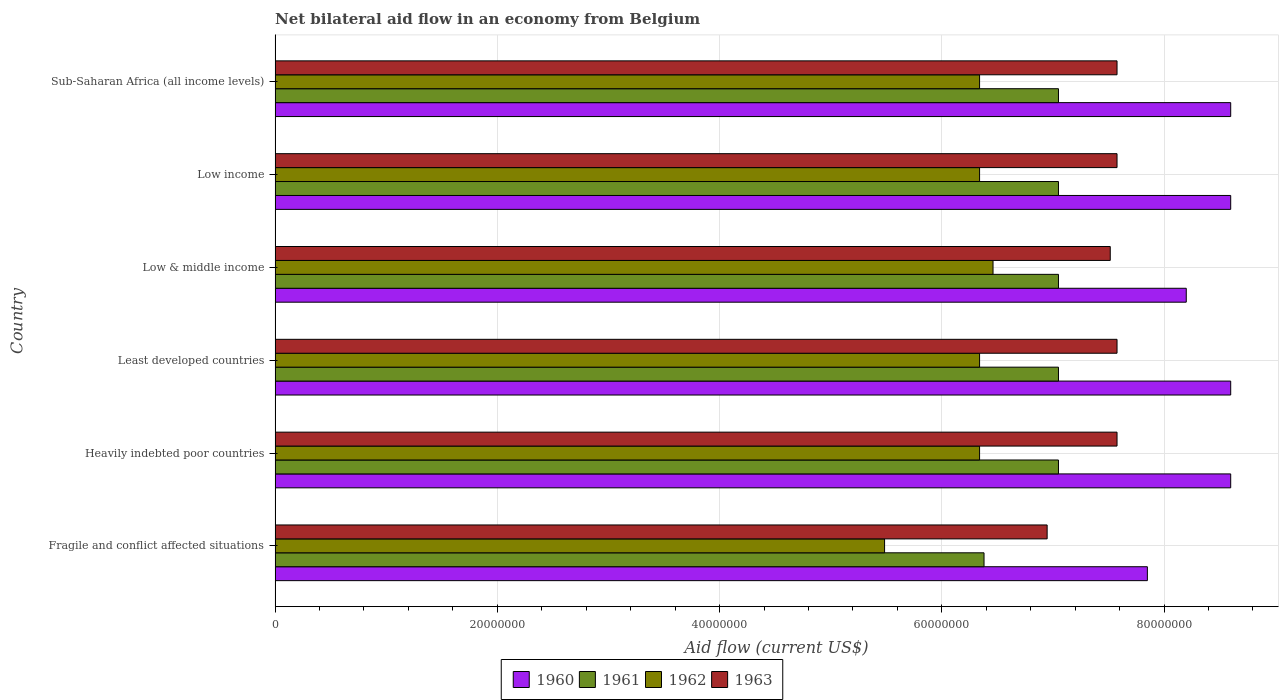Are the number of bars on each tick of the Y-axis equal?
Provide a succinct answer. Yes. How many bars are there on the 3rd tick from the top?
Offer a terse response. 4. How many bars are there on the 4th tick from the bottom?
Provide a succinct answer. 4. In how many cases, is the number of bars for a given country not equal to the number of legend labels?
Offer a very short reply. 0. What is the net bilateral aid flow in 1962 in Least developed countries?
Make the answer very short. 6.34e+07. Across all countries, what is the maximum net bilateral aid flow in 1961?
Your answer should be compact. 7.05e+07. Across all countries, what is the minimum net bilateral aid flow in 1963?
Make the answer very short. 6.95e+07. In which country was the net bilateral aid flow in 1960 maximum?
Your answer should be very brief. Heavily indebted poor countries. In which country was the net bilateral aid flow in 1960 minimum?
Offer a terse response. Fragile and conflict affected situations. What is the total net bilateral aid flow in 1961 in the graph?
Your answer should be compact. 4.16e+08. What is the difference between the net bilateral aid flow in 1963 in Fragile and conflict affected situations and that in Heavily indebted poor countries?
Offer a terse response. -6.29e+06. What is the difference between the net bilateral aid flow in 1961 in Fragile and conflict affected situations and the net bilateral aid flow in 1962 in Least developed countries?
Make the answer very short. 4.00e+05. What is the average net bilateral aid flow in 1960 per country?
Provide a succinct answer. 8.41e+07. What is the difference between the net bilateral aid flow in 1962 and net bilateral aid flow in 1961 in Sub-Saharan Africa (all income levels)?
Keep it short and to the point. -7.10e+06. In how many countries, is the net bilateral aid flow in 1963 greater than 64000000 US$?
Your answer should be very brief. 6. What is the ratio of the net bilateral aid flow in 1962 in Fragile and conflict affected situations to that in Sub-Saharan Africa (all income levels)?
Ensure brevity in your answer.  0.87. Is the net bilateral aid flow in 1961 in Heavily indebted poor countries less than that in Low income?
Your response must be concise. No. Is the difference between the net bilateral aid flow in 1962 in Low income and Sub-Saharan Africa (all income levels) greater than the difference between the net bilateral aid flow in 1961 in Low income and Sub-Saharan Africa (all income levels)?
Provide a succinct answer. No. What is the difference between the highest and the lowest net bilateral aid flow in 1960?
Make the answer very short. 7.50e+06. What does the 4th bar from the top in Fragile and conflict affected situations represents?
Keep it short and to the point. 1960. Is it the case that in every country, the sum of the net bilateral aid flow in 1961 and net bilateral aid flow in 1960 is greater than the net bilateral aid flow in 1962?
Your answer should be compact. Yes. How many bars are there?
Offer a terse response. 24. How many countries are there in the graph?
Your answer should be very brief. 6. Are the values on the major ticks of X-axis written in scientific E-notation?
Provide a short and direct response. No. Where does the legend appear in the graph?
Offer a very short reply. Bottom center. How many legend labels are there?
Your answer should be compact. 4. What is the title of the graph?
Make the answer very short. Net bilateral aid flow in an economy from Belgium. What is the label or title of the Y-axis?
Your answer should be compact. Country. What is the Aid flow (current US$) in 1960 in Fragile and conflict affected situations?
Your answer should be compact. 7.85e+07. What is the Aid flow (current US$) in 1961 in Fragile and conflict affected situations?
Keep it short and to the point. 6.38e+07. What is the Aid flow (current US$) of 1962 in Fragile and conflict affected situations?
Your answer should be compact. 5.48e+07. What is the Aid flow (current US$) in 1963 in Fragile and conflict affected situations?
Your answer should be very brief. 6.95e+07. What is the Aid flow (current US$) of 1960 in Heavily indebted poor countries?
Your answer should be compact. 8.60e+07. What is the Aid flow (current US$) of 1961 in Heavily indebted poor countries?
Provide a short and direct response. 7.05e+07. What is the Aid flow (current US$) of 1962 in Heavily indebted poor countries?
Ensure brevity in your answer.  6.34e+07. What is the Aid flow (current US$) in 1963 in Heavily indebted poor countries?
Offer a terse response. 7.58e+07. What is the Aid flow (current US$) in 1960 in Least developed countries?
Ensure brevity in your answer.  8.60e+07. What is the Aid flow (current US$) in 1961 in Least developed countries?
Your answer should be very brief. 7.05e+07. What is the Aid flow (current US$) in 1962 in Least developed countries?
Your answer should be compact. 6.34e+07. What is the Aid flow (current US$) of 1963 in Least developed countries?
Ensure brevity in your answer.  7.58e+07. What is the Aid flow (current US$) in 1960 in Low & middle income?
Your answer should be very brief. 8.20e+07. What is the Aid flow (current US$) in 1961 in Low & middle income?
Make the answer very short. 7.05e+07. What is the Aid flow (current US$) in 1962 in Low & middle income?
Provide a short and direct response. 6.46e+07. What is the Aid flow (current US$) of 1963 in Low & middle income?
Keep it short and to the point. 7.52e+07. What is the Aid flow (current US$) of 1960 in Low income?
Give a very brief answer. 8.60e+07. What is the Aid flow (current US$) in 1961 in Low income?
Your answer should be very brief. 7.05e+07. What is the Aid flow (current US$) in 1962 in Low income?
Your response must be concise. 6.34e+07. What is the Aid flow (current US$) of 1963 in Low income?
Keep it short and to the point. 7.58e+07. What is the Aid flow (current US$) in 1960 in Sub-Saharan Africa (all income levels)?
Your answer should be compact. 8.60e+07. What is the Aid flow (current US$) in 1961 in Sub-Saharan Africa (all income levels)?
Provide a short and direct response. 7.05e+07. What is the Aid flow (current US$) in 1962 in Sub-Saharan Africa (all income levels)?
Provide a short and direct response. 6.34e+07. What is the Aid flow (current US$) in 1963 in Sub-Saharan Africa (all income levels)?
Your answer should be very brief. 7.58e+07. Across all countries, what is the maximum Aid flow (current US$) in 1960?
Your answer should be very brief. 8.60e+07. Across all countries, what is the maximum Aid flow (current US$) in 1961?
Your response must be concise. 7.05e+07. Across all countries, what is the maximum Aid flow (current US$) in 1962?
Give a very brief answer. 6.46e+07. Across all countries, what is the maximum Aid flow (current US$) in 1963?
Offer a very short reply. 7.58e+07. Across all countries, what is the minimum Aid flow (current US$) of 1960?
Your response must be concise. 7.85e+07. Across all countries, what is the minimum Aid flow (current US$) of 1961?
Keep it short and to the point. 6.38e+07. Across all countries, what is the minimum Aid flow (current US$) in 1962?
Provide a succinct answer. 5.48e+07. Across all countries, what is the minimum Aid flow (current US$) in 1963?
Ensure brevity in your answer.  6.95e+07. What is the total Aid flow (current US$) of 1960 in the graph?
Ensure brevity in your answer.  5.04e+08. What is the total Aid flow (current US$) of 1961 in the graph?
Offer a very short reply. 4.16e+08. What is the total Aid flow (current US$) of 1962 in the graph?
Your answer should be compact. 3.73e+08. What is the total Aid flow (current US$) in 1963 in the graph?
Ensure brevity in your answer.  4.48e+08. What is the difference between the Aid flow (current US$) of 1960 in Fragile and conflict affected situations and that in Heavily indebted poor countries?
Your answer should be compact. -7.50e+06. What is the difference between the Aid flow (current US$) of 1961 in Fragile and conflict affected situations and that in Heavily indebted poor countries?
Offer a terse response. -6.70e+06. What is the difference between the Aid flow (current US$) in 1962 in Fragile and conflict affected situations and that in Heavily indebted poor countries?
Keep it short and to the point. -8.55e+06. What is the difference between the Aid flow (current US$) in 1963 in Fragile and conflict affected situations and that in Heavily indebted poor countries?
Your answer should be compact. -6.29e+06. What is the difference between the Aid flow (current US$) of 1960 in Fragile and conflict affected situations and that in Least developed countries?
Provide a succinct answer. -7.50e+06. What is the difference between the Aid flow (current US$) of 1961 in Fragile and conflict affected situations and that in Least developed countries?
Offer a very short reply. -6.70e+06. What is the difference between the Aid flow (current US$) in 1962 in Fragile and conflict affected situations and that in Least developed countries?
Make the answer very short. -8.55e+06. What is the difference between the Aid flow (current US$) of 1963 in Fragile and conflict affected situations and that in Least developed countries?
Provide a short and direct response. -6.29e+06. What is the difference between the Aid flow (current US$) in 1960 in Fragile and conflict affected situations and that in Low & middle income?
Provide a succinct answer. -3.50e+06. What is the difference between the Aid flow (current US$) of 1961 in Fragile and conflict affected situations and that in Low & middle income?
Provide a short and direct response. -6.70e+06. What is the difference between the Aid flow (current US$) in 1962 in Fragile and conflict affected situations and that in Low & middle income?
Give a very brief answer. -9.76e+06. What is the difference between the Aid flow (current US$) in 1963 in Fragile and conflict affected situations and that in Low & middle income?
Give a very brief answer. -5.68e+06. What is the difference between the Aid flow (current US$) of 1960 in Fragile and conflict affected situations and that in Low income?
Provide a succinct answer. -7.50e+06. What is the difference between the Aid flow (current US$) of 1961 in Fragile and conflict affected situations and that in Low income?
Your answer should be compact. -6.70e+06. What is the difference between the Aid flow (current US$) in 1962 in Fragile and conflict affected situations and that in Low income?
Give a very brief answer. -8.55e+06. What is the difference between the Aid flow (current US$) of 1963 in Fragile and conflict affected situations and that in Low income?
Offer a very short reply. -6.29e+06. What is the difference between the Aid flow (current US$) in 1960 in Fragile and conflict affected situations and that in Sub-Saharan Africa (all income levels)?
Provide a succinct answer. -7.50e+06. What is the difference between the Aid flow (current US$) of 1961 in Fragile and conflict affected situations and that in Sub-Saharan Africa (all income levels)?
Ensure brevity in your answer.  -6.70e+06. What is the difference between the Aid flow (current US$) in 1962 in Fragile and conflict affected situations and that in Sub-Saharan Africa (all income levels)?
Your answer should be compact. -8.55e+06. What is the difference between the Aid flow (current US$) in 1963 in Fragile and conflict affected situations and that in Sub-Saharan Africa (all income levels)?
Provide a short and direct response. -6.29e+06. What is the difference between the Aid flow (current US$) of 1962 in Heavily indebted poor countries and that in Least developed countries?
Your response must be concise. 0. What is the difference between the Aid flow (current US$) in 1963 in Heavily indebted poor countries and that in Least developed countries?
Provide a short and direct response. 0. What is the difference between the Aid flow (current US$) of 1961 in Heavily indebted poor countries and that in Low & middle income?
Offer a terse response. 0. What is the difference between the Aid flow (current US$) in 1962 in Heavily indebted poor countries and that in Low & middle income?
Ensure brevity in your answer.  -1.21e+06. What is the difference between the Aid flow (current US$) in 1963 in Heavily indebted poor countries and that in Low & middle income?
Make the answer very short. 6.10e+05. What is the difference between the Aid flow (current US$) of 1961 in Heavily indebted poor countries and that in Low income?
Give a very brief answer. 0. What is the difference between the Aid flow (current US$) in 1960 in Heavily indebted poor countries and that in Sub-Saharan Africa (all income levels)?
Keep it short and to the point. 0. What is the difference between the Aid flow (current US$) in 1962 in Heavily indebted poor countries and that in Sub-Saharan Africa (all income levels)?
Offer a very short reply. 0. What is the difference between the Aid flow (current US$) in 1960 in Least developed countries and that in Low & middle income?
Provide a short and direct response. 4.00e+06. What is the difference between the Aid flow (current US$) in 1961 in Least developed countries and that in Low & middle income?
Provide a short and direct response. 0. What is the difference between the Aid flow (current US$) in 1962 in Least developed countries and that in Low & middle income?
Your answer should be very brief. -1.21e+06. What is the difference between the Aid flow (current US$) in 1962 in Least developed countries and that in Low income?
Make the answer very short. 0. What is the difference between the Aid flow (current US$) in 1963 in Least developed countries and that in Low income?
Your response must be concise. 0. What is the difference between the Aid flow (current US$) of 1961 in Least developed countries and that in Sub-Saharan Africa (all income levels)?
Your answer should be very brief. 0. What is the difference between the Aid flow (current US$) of 1962 in Least developed countries and that in Sub-Saharan Africa (all income levels)?
Your answer should be very brief. 0. What is the difference between the Aid flow (current US$) in 1963 in Least developed countries and that in Sub-Saharan Africa (all income levels)?
Make the answer very short. 0. What is the difference between the Aid flow (current US$) of 1962 in Low & middle income and that in Low income?
Give a very brief answer. 1.21e+06. What is the difference between the Aid flow (current US$) of 1963 in Low & middle income and that in Low income?
Offer a very short reply. -6.10e+05. What is the difference between the Aid flow (current US$) in 1961 in Low & middle income and that in Sub-Saharan Africa (all income levels)?
Keep it short and to the point. 0. What is the difference between the Aid flow (current US$) in 1962 in Low & middle income and that in Sub-Saharan Africa (all income levels)?
Keep it short and to the point. 1.21e+06. What is the difference between the Aid flow (current US$) of 1963 in Low & middle income and that in Sub-Saharan Africa (all income levels)?
Keep it short and to the point. -6.10e+05. What is the difference between the Aid flow (current US$) of 1960 in Low income and that in Sub-Saharan Africa (all income levels)?
Provide a succinct answer. 0. What is the difference between the Aid flow (current US$) in 1961 in Low income and that in Sub-Saharan Africa (all income levels)?
Your response must be concise. 0. What is the difference between the Aid flow (current US$) in 1962 in Low income and that in Sub-Saharan Africa (all income levels)?
Offer a terse response. 0. What is the difference between the Aid flow (current US$) of 1960 in Fragile and conflict affected situations and the Aid flow (current US$) of 1961 in Heavily indebted poor countries?
Your answer should be compact. 8.00e+06. What is the difference between the Aid flow (current US$) of 1960 in Fragile and conflict affected situations and the Aid flow (current US$) of 1962 in Heavily indebted poor countries?
Give a very brief answer. 1.51e+07. What is the difference between the Aid flow (current US$) of 1960 in Fragile and conflict affected situations and the Aid flow (current US$) of 1963 in Heavily indebted poor countries?
Your answer should be very brief. 2.73e+06. What is the difference between the Aid flow (current US$) in 1961 in Fragile and conflict affected situations and the Aid flow (current US$) in 1962 in Heavily indebted poor countries?
Give a very brief answer. 4.00e+05. What is the difference between the Aid flow (current US$) in 1961 in Fragile and conflict affected situations and the Aid flow (current US$) in 1963 in Heavily indebted poor countries?
Provide a succinct answer. -1.20e+07. What is the difference between the Aid flow (current US$) of 1962 in Fragile and conflict affected situations and the Aid flow (current US$) of 1963 in Heavily indebted poor countries?
Provide a short and direct response. -2.09e+07. What is the difference between the Aid flow (current US$) in 1960 in Fragile and conflict affected situations and the Aid flow (current US$) in 1961 in Least developed countries?
Ensure brevity in your answer.  8.00e+06. What is the difference between the Aid flow (current US$) in 1960 in Fragile and conflict affected situations and the Aid flow (current US$) in 1962 in Least developed countries?
Keep it short and to the point. 1.51e+07. What is the difference between the Aid flow (current US$) of 1960 in Fragile and conflict affected situations and the Aid flow (current US$) of 1963 in Least developed countries?
Give a very brief answer. 2.73e+06. What is the difference between the Aid flow (current US$) in 1961 in Fragile and conflict affected situations and the Aid flow (current US$) in 1963 in Least developed countries?
Your answer should be compact. -1.20e+07. What is the difference between the Aid flow (current US$) in 1962 in Fragile and conflict affected situations and the Aid flow (current US$) in 1963 in Least developed countries?
Your answer should be very brief. -2.09e+07. What is the difference between the Aid flow (current US$) of 1960 in Fragile and conflict affected situations and the Aid flow (current US$) of 1961 in Low & middle income?
Provide a succinct answer. 8.00e+06. What is the difference between the Aid flow (current US$) in 1960 in Fragile and conflict affected situations and the Aid flow (current US$) in 1962 in Low & middle income?
Your response must be concise. 1.39e+07. What is the difference between the Aid flow (current US$) in 1960 in Fragile and conflict affected situations and the Aid flow (current US$) in 1963 in Low & middle income?
Give a very brief answer. 3.34e+06. What is the difference between the Aid flow (current US$) of 1961 in Fragile and conflict affected situations and the Aid flow (current US$) of 1962 in Low & middle income?
Give a very brief answer. -8.10e+05. What is the difference between the Aid flow (current US$) of 1961 in Fragile and conflict affected situations and the Aid flow (current US$) of 1963 in Low & middle income?
Provide a succinct answer. -1.14e+07. What is the difference between the Aid flow (current US$) of 1962 in Fragile and conflict affected situations and the Aid flow (current US$) of 1963 in Low & middle income?
Make the answer very short. -2.03e+07. What is the difference between the Aid flow (current US$) in 1960 in Fragile and conflict affected situations and the Aid flow (current US$) in 1962 in Low income?
Your response must be concise. 1.51e+07. What is the difference between the Aid flow (current US$) of 1960 in Fragile and conflict affected situations and the Aid flow (current US$) of 1963 in Low income?
Give a very brief answer. 2.73e+06. What is the difference between the Aid flow (current US$) in 1961 in Fragile and conflict affected situations and the Aid flow (current US$) in 1963 in Low income?
Your answer should be compact. -1.20e+07. What is the difference between the Aid flow (current US$) of 1962 in Fragile and conflict affected situations and the Aid flow (current US$) of 1963 in Low income?
Ensure brevity in your answer.  -2.09e+07. What is the difference between the Aid flow (current US$) of 1960 in Fragile and conflict affected situations and the Aid flow (current US$) of 1961 in Sub-Saharan Africa (all income levels)?
Make the answer very short. 8.00e+06. What is the difference between the Aid flow (current US$) of 1960 in Fragile and conflict affected situations and the Aid flow (current US$) of 1962 in Sub-Saharan Africa (all income levels)?
Offer a terse response. 1.51e+07. What is the difference between the Aid flow (current US$) in 1960 in Fragile and conflict affected situations and the Aid flow (current US$) in 1963 in Sub-Saharan Africa (all income levels)?
Make the answer very short. 2.73e+06. What is the difference between the Aid flow (current US$) in 1961 in Fragile and conflict affected situations and the Aid flow (current US$) in 1963 in Sub-Saharan Africa (all income levels)?
Your response must be concise. -1.20e+07. What is the difference between the Aid flow (current US$) in 1962 in Fragile and conflict affected situations and the Aid flow (current US$) in 1963 in Sub-Saharan Africa (all income levels)?
Your answer should be very brief. -2.09e+07. What is the difference between the Aid flow (current US$) in 1960 in Heavily indebted poor countries and the Aid flow (current US$) in 1961 in Least developed countries?
Offer a very short reply. 1.55e+07. What is the difference between the Aid flow (current US$) in 1960 in Heavily indebted poor countries and the Aid flow (current US$) in 1962 in Least developed countries?
Make the answer very short. 2.26e+07. What is the difference between the Aid flow (current US$) of 1960 in Heavily indebted poor countries and the Aid flow (current US$) of 1963 in Least developed countries?
Your answer should be compact. 1.02e+07. What is the difference between the Aid flow (current US$) in 1961 in Heavily indebted poor countries and the Aid flow (current US$) in 1962 in Least developed countries?
Your response must be concise. 7.10e+06. What is the difference between the Aid flow (current US$) in 1961 in Heavily indebted poor countries and the Aid flow (current US$) in 1963 in Least developed countries?
Make the answer very short. -5.27e+06. What is the difference between the Aid flow (current US$) in 1962 in Heavily indebted poor countries and the Aid flow (current US$) in 1963 in Least developed countries?
Your answer should be very brief. -1.24e+07. What is the difference between the Aid flow (current US$) of 1960 in Heavily indebted poor countries and the Aid flow (current US$) of 1961 in Low & middle income?
Your answer should be very brief. 1.55e+07. What is the difference between the Aid flow (current US$) in 1960 in Heavily indebted poor countries and the Aid flow (current US$) in 1962 in Low & middle income?
Your response must be concise. 2.14e+07. What is the difference between the Aid flow (current US$) in 1960 in Heavily indebted poor countries and the Aid flow (current US$) in 1963 in Low & middle income?
Make the answer very short. 1.08e+07. What is the difference between the Aid flow (current US$) in 1961 in Heavily indebted poor countries and the Aid flow (current US$) in 1962 in Low & middle income?
Offer a terse response. 5.89e+06. What is the difference between the Aid flow (current US$) of 1961 in Heavily indebted poor countries and the Aid flow (current US$) of 1963 in Low & middle income?
Make the answer very short. -4.66e+06. What is the difference between the Aid flow (current US$) in 1962 in Heavily indebted poor countries and the Aid flow (current US$) in 1963 in Low & middle income?
Give a very brief answer. -1.18e+07. What is the difference between the Aid flow (current US$) in 1960 in Heavily indebted poor countries and the Aid flow (current US$) in 1961 in Low income?
Make the answer very short. 1.55e+07. What is the difference between the Aid flow (current US$) in 1960 in Heavily indebted poor countries and the Aid flow (current US$) in 1962 in Low income?
Ensure brevity in your answer.  2.26e+07. What is the difference between the Aid flow (current US$) of 1960 in Heavily indebted poor countries and the Aid flow (current US$) of 1963 in Low income?
Ensure brevity in your answer.  1.02e+07. What is the difference between the Aid flow (current US$) of 1961 in Heavily indebted poor countries and the Aid flow (current US$) of 1962 in Low income?
Keep it short and to the point. 7.10e+06. What is the difference between the Aid flow (current US$) of 1961 in Heavily indebted poor countries and the Aid flow (current US$) of 1963 in Low income?
Ensure brevity in your answer.  -5.27e+06. What is the difference between the Aid flow (current US$) of 1962 in Heavily indebted poor countries and the Aid flow (current US$) of 1963 in Low income?
Your answer should be very brief. -1.24e+07. What is the difference between the Aid flow (current US$) of 1960 in Heavily indebted poor countries and the Aid flow (current US$) of 1961 in Sub-Saharan Africa (all income levels)?
Ensure brevity in your answer.  1.55e+07. What is the difference between the Aid flow (current US$) in 1960 in Heavily indebted poor countries and the Aid flow (current US$) in 1962 in Sub-Saharan Africa (all income levels)?
Make the answer very short. 2.26e+07. What is the difference between the Aid flow (current US$) in 1960 in Heavily indebted poor countries and the Aid flow (current US$) in 1963 in Sub-Saharan Africa (all income levels)?
Ensure brevity in your answer.  1.02e+07. What is the difference between the Aid flow (current US$) in 1961 in Heavily indebted poor countries and the Aid flow (current US$) in 1962 in Sub-Saharan Africa (all income levels)?
Give a very brief answer. 7.10e+06. What is the difference between the Aid flow (current US$) of 1961 in Heavily indebted poor countries and the Aid flow (current US$) of 1963 in Sub-Saharan Africa (all income levels)?
Your response must be concise. -5.27e+06. What is the difference between the Aid flow (current US$) of 1962 in Heavily indebted poor countries and the Aid flow (current US$) of 1963 in Sub-Saharan Africa (all income levels)?
Keep it short and to the point. -1.24e+07. What is the difference between the Aid flow (current US$) of 1960 in Least developed countries and the Aid flow (current US$) of 1961 in Low & middle income?
Your answer should be very brief. 1.55e+07. What is the difference between the Aid flow (current US$) in 1960 in Least developed countries and the Aid flow (current US$) in 1962 in Low & middle income?
Ensure brevity in your answer.  2.14e+07. What is the difference between the Aid flow (current US$) of 1960 in Least developed countries and the Aid flow (current US$) of 1963 in Low & middle income?
Keep it short and to the point. 1.08e+07. What is the difference between the Aid flow (current US$) in 1961 in Least developed countries and the Aid flow (current US$) in 1962 in Low & middle income?
Keep it short and to the point. 5.89e+06. What is the difference between the Aid flow (current US$) in 1961 in Least developed countries and the Aid flow (current US$) in 1963 in Low & middle income?
Provide a short and direct response. -4.66e+06. What is the difference between the Aid flow (current US$) of 1962 in Least developed countries and the Aid flow (current US$) of 1963 in Low & middle income?
Make the answer very short. -1.18e+07. What is the difference between the Aid flow (current US$) in 1960 in Least developed countries and the Aid flow (current US$) in 1961 in Low income?
Ensure brevity in your answer.  1.55e+07. What is the difference between the Aid flow (current US$) of 1960 in Least developed countries and the Aid flow (current US$) of 1962 in Low income?
Provide a short and direct response. 2.26e+07. What is the difference between the Aid flow (current US$) of 1960 in Least developed countries and the Aid flow (current US$) of 1963 in Low income?
Offer a very short reply. 1.02e+07. What is the difference between the Aid flow (current US$) of 1961 in Least developed countries and the Aid flow (current US$) of 1962 in Low income?
Your answer should be very brief. 7.10e+06. What is the difference between the Aid flow (current US$) in 1961 in Least developed countries and the Aid flow (current US$) in 1963 in Low income?
Give a very brief answer. -5.27e+06. What is the difference between the Aid flow (current US$) of 1962 in Least developed countries and the Aid flow (current US$) of 1963 in Low income?
Your answer should be compact. -1.24e+07. What is the difference between the Aid flow (current US$) of 1960 in Least developed countries and the Aid flow (current US$) of 1961 in Sub-Saharan Africa (all income levels)?
Your response must be concise. 1.55e+07. What is the difference between the Aid flow (current US$) in 1960 in Least developed countries and the Aid flow (current US$) in 1962 in Sub-Saharan Africa (all income levels)?
Provide a succinct answer. 2.26e+07. What is the difference between the Aid flow (current US$) in 1960 in Least developed countries and the Aid flow (current US$) in 1963 in Sub-Saharan Africa (all income levels)?
Ensure brevity in your answer.  1.02e+07. What is the difference between the Aid flow (current US$) of 1961 in Least developed countries and the Aid flow (current US$) of 1962 in Sub-Saharan Africa (all income levels)?
Your answer should be very brief. 7.10e+06. What is the difference between the Aid flow (current US$) in 1961 in Least developed countries and the Aid flow (current US$) in 1963 in Sub-Saharan Africa (all income levels)?
Make the answer very short. -5.27e+06. What is the difference between the Aid flow (current US$) in 1962 in Least developed countries and the Aid flow (current US$) in 1963 in Sub-Saharan Africa (all income levels)?
Your answer should be very brief. -1.24e+07. What is the difference between the Aid flow (current US$) of 1960 in Low & middle income and the Aid flow (current US$) of 1961 in Low income?
Your answer should be compact. 1.15e+07. What is the difference between the Aid flow (current US$) of 1960 in Low & middle income and the Aid flow (current US$) of 1962 in Low income?
Make the answer very short. 1.86e+07. What is the difference between the Aid flow (current US$) of 1960 in Low & middle income and the Aid flow (current US$) of 1963 in Low income?
Make the answer very short. 6.23e+06. What is the difference between the Aid flow (current US$) of 1961 in Low & middle income and the Aid flow (current US$) of 1962 in Low income?
Keep it short and to the point. 7.10e+06. What is the difference between the Aid flow (current US$) in 1961 in Low & middle income and the Aid flow (current US$) in 1963 in Low income?
Keep it short and to the point. -5.27e+06. What is the difference between the Aid flow (current US$) of 1962 in Low & middle income and the Aid flow (current US$) of 1963 in Low income?
Keep it short and to the point. -1.12e+07. What is the difference between the Aid flow (current US$) of 1960 in Low & middle income and the Aid flow (current US$) of 1961 in Sub-Saharan Africa (all income levels)?
Offer a very short reply. 1.15e+07. What is the difference between the Aid flow (current US$) in 1960 in Low & middle income and the Aid flow (current US$) in 1962 in Sub-Saharan Africa (all income levels)?
Offer a terse response. 1.86e+07. What is the difference between the Aid flow (current US$) of 1960 in Low & middle income and the Aid flow (current US$) of 1963 in Sub-Saharan Africa (all income levels)?
Offer a very short reply. 6.23e+06. What is the difference between the Aid flow (current US$) in 1961 in Low & middle income and the Aid flow (current US$) in 1962 in Sub-Saharan Africa (all income levels)?
Make the answer very short. 7.10e+06. What is the difference between the Aid flow (current US$) in 1961 in Low & middle income and the Aid flow (current US$) in 1963 in Sub-Saharan Africa (all income levels)?
Provide a short and direct response. -5.27e+06. What is the difference between the Aid flow (current US$) in 1962 in Low & middle income and the Aid flow (current US$) in 1963 in Sub-Saharan Africa (all income levels)?
Offer a very short reply. -1.12e+07. What is the difference between the Aid flow (current US$) in 1960 in Low income and the Aid flow (current US$) in 1961 in Sub-Saharan Africa (all income levels)?
Give a very brief answer. 1.55e+07. What is the difference between the Aid flow (current US$) in 1960 in Low income and the Aid flow (current US$) in 1962 in Sub-Saharan Africa (all income levels)?
Your answer should be compact. 2.26e+07. What is the difference between the Aid flow (current US$) of 1960 in Low income and the Aid flow (current US$) of 1963 in Sub-Saharan Africa (all income levels)?
Your response must be concise. 1.02e+07. What is the difference between the Aid flow (current US$) of 1961 in Low income and the Aid flow (current US$) of 1962 in Sub-Saharan Africa (all income levels)?
Provide a short and direct response. 7.10e+06. What is the difference between the Aid flow (current US$) in 1961 in Low income and the Aid flow (current US$) in 1963 in Sub-Saharan Africa (all income levels)?
Make the answer very short. -5.27e+06. What is the difference between the Aid flow (current US$) in 1962 in Low income and the Aid flow (current US$) in 1963 in Sub-Saharan Africa (all income levels)?
Your answer should be very brief. -1.24e+07. What is the average Aid flow (current US$) of 1960 per country?
Your response must be concise. 8.41e+07. What is the average Aid flow (current US$) in 1961 per country?
Your answer should be very brief. 6.94e+07. What is the average Aid flow (current US$) in 1962 per country?
Your answer should be very brief. 6.22e+07. What is the average Aid flow (current US$) in 1963 per country?
Your answer should be compact. 7.46e+07. What is the difference between the Aid flow (current US$) of 1960 and Aid flow (current US$) of 1961 in Fragile and conflict affected situations?
Offer a very short reply. 1.47e+07. What is the difference between the Aid flow (current US$) in 1960 and Aid flow (current US$) in 1962 in Fragile and conflict affected situations?
Keep it short and to the point. 2.36e+07. What is the difference between the Aid flow (current US$) in 1960 and Aid flow (current US$) in 1963 in Fragile and conflict affected situations?
Your response must be concise. 9.02e+06. What is the difference between the Aid flow (current US$) of 1961 and Aid flow (current US$) of 1962 in Fragile and conflict affected situations?
Keep it short and to the point. 8.95e+06. What is the difference between the Aid flow (current US$) of 1961 and Aid flow (current US$) of 1963 in Fragile and conflict affected situations?
Make the answer very short. -5.68e+06. What is the difference between the Aid flow (current US$) of 1962 and Aid flow (current US$) of 1963 in Fragile and conflict affected situations?
Your response must be concise. -1.46e+07. What is the difference between the Aid flow (current US$) of 1960 and Aid flow (current US$) of 1961 in Heavily indebted poor countries?
Ensure brevity in your answer.  1.55e+07. What is the difference between the Aid flow (current US$) of 1960 and Aid flow (current US$) of 1962 in Heavily indebted poor countries?
Provide a succinct answer. 2.26e+07. What is the difference between the Aid flow (current US$) of 1960 and Aid flow (current US$) of 1963 in Heavily indebted poor countries?
Your answer should be very brief. 1.02e+07. What is the difference between the Aid flow (current US$) in 1961 and Aid flow (current US$) in 1962 in Heavily indebted poor countries?
Your answer should be very brief. 7.10e+06. What is the difference between the Aid flow (current US$) of 1961 and Aid flow (current US$) of 1963 in Heavily indebted poor countries?
Make the answer very short. -5.27e+06. What is the difference between the Aid flow (current US$) in 1962 and Aid flow (current US$) in 1963 in Heavily indebted poor countries?
Give a very brief answer. -1.24e+07. What is the difference between the Aid flow (current US$) in 1960 and Aid flow (current US$) in 1961 in Least developed countries?
Your response must be concise. 1.55e+07. What is the difference between the Aid flow (current US$) of 1960 and Aid flow (current US$) of 1962 in Least developed countries?
Provide a short and direct response. 2.26e+07. What is the difference between the Aid flow (current US$) in 1960 and Aid flow (current US$) in 1963 in Least developed countries?
Keep it short and to the point. 1.02e+07. What is the difference between the Aid flow (current US$) in 1961 and Aid flow (current US$) in 1962 in Least developed countries?
Your answer should be compact. 7.10e+06. What is the difference between the Aid flow (current US$) of 1961 and Aid flow (current US$) of 1963 in Least developed countries?
Provide a succinct answer. -5.27e+06. What is the difference between the Aid flow (current US$) of 1962 and Aid flow (current US$) of 1963 in Least developed countries?
Offer a terse response. -1.24e+07. What is the difference between the Aid flow (current US$) of 1960 and Aid flow (current US$) of 1961 in Low & middle income?
Keep it short and to the point. 1.15e+07. What is the difference between the Aid flow (current US$) in 1960 and Aid flow (current US$) in 1962 in Low & middle income?
Your answer should be very brief. 1.74e+07. What is the difference between the Aid flow (current US$) in 1960 and Aid flow (current US$) in 1963 in Low & middle income?
Ensure brevity in your answer.  6.84e+06. What is the difference between the Aid flow (current US$) in 1961 and Aid flow (current US$) in 1962 in Low & middle income?
Your response must be concise. 5.89e+06. What is the difference between the Aid flow (current US$) of 1961 and Aid flow (current US$) of 1963 in Low & middle income?
Keep it short and to the point. -4.66e+06. What is the difference between the Aid flow (current US$) of 1962 and Aid flow (current US$) of 1963 in Low & middle income?
Keep it short and to the point. -1.06e+07. What is the difference between the Aid flow (current US$) in 1960 and Aid flow (current US$) in 1961 in Low income?
Make the answer very short. 1.55e+07. What is the difference between the Aid flow (current US$) of 1960 and Aid flow (current US$) of 1962 in Low income?
Your answer should be very brief. 2.26e+07. What is the difference between the Aid flow (current US$) of 1960 and Aid flow (current US$) of 1963 in Low income?
Provide a short and direct response. 1.02e+07. What is the difference between the Aid flow (current US$) in 1961 and Aid flow (current US$) in 1962 in Low income?
Make the answer very short. 7.10e+06. What is the difference between the Aid flow (current US$) in 1961 and Aid flow (current US$) in 1963 in Low income?
Your answer should be compact. -5.27e+06. What is the difference between the Aid flow (current US$) in 1962 and Aid flow (current US$) in 1963 in Low income?
Ensure brevity in your answer.  -1.24e+07. What is the difference between the Aid flow (current US$) of 1960 and Aid flow (current US$) of 1961 in Sub-Saharan Africa (all income levels)?
Make the answer very short. 1.55e+07. What is the difference between the Aid flow (current US$) in 1960 and Aid flow (current US$) in 1962 in Sub-Saharan Africa (all income levels)?
Your response must be concise. 2.26e+07. What is the difference between the Aid flow (current US$) in 1960 and Aid flow (current US$) in 1963 in Sub-Saharan Africa (all income levels)?
Keep it short and to the point. 1.02e+07. What is the difference between the Aid flow (current US$) of 1961 and Aid flow (current US$) of 1962 in Sub-Saharan Africa (all income levels)?
Your answer should be compact. 7.10e+06. What is the difference between the Aid flow (current US$) of 1961 and Aid flow (current US$) of 1963 in Sub-Saharan Africa (all income levels)?
Offer a very short reply. -5.27e+06. What is the difference between the Aid flow (current US$) in 1962 and Aid flow (current US$) in 1963 in Sub-Saharan Africa (all income levels)?
Make the answer very short. -1.24e+07. What is the ratio of the Aid flow (current US$) in 1960 in Fragile and conflict affected situations to that in Heavily indebted poor countries?
Your answer should be compact. 0.91. What is the ratio of the Aid flow (current US$) in 1961 in Fragile and conflict affected situations to that in Heavily indebted poor countries?
Make the answer very short. 0.91. What is the ratio of the Aid flow (current US$) in 1962 in Fragile and conflict affected situations to that in Heavily indebted poor countries?
Your answer should be very brief. 0.87. What is the ratio of the Aid flow (current US$) of 1963 in Fragile and conflict affected situations to that in Heavily indebted poor countries?
Your response must be concise. 0.92. What is the ratio of the Aid flow (current US$) in 1960 in Fragile and conflict affected situations to that in Least developed countries?
Provide a succinct answer. 0.91. What is the ratio of the Aid flow (current US$) of 1961 in Fragile and conflict affected situations to that in Least developed countries?
Provide a succinct answer. 0.91. What is the ratio of the Aid flow (current US$) of 1962 in Fragile and conflict affected situations to that in Least developed countries?
Make the answer very short. 0.87. What is the ratio of the Aid flow (current US$) of 1963 in Fragile and conflict affected situations to that in Least developed countries?
Offer a very short reply. 0.92. What is the ratio of the Aid flow (current US$) of 1960 in Fragile and conflict affected situations to that in Low & middle income?
Your answer should be very brief. 0.96. What is the ratio of the Aid flow (current US$) of 1961 in Fragile and conflict affected situations to that in Low & middle income?
Offer a very short reply. 0.91. What is the ratio of the Aid flow (current US$) in 1962 in Fragile and conflict affected situations to that in Low & middle income?
Provide a succinct answer. 0.85. What is the ratio of the Aid flow (current US$) in 1963 in Fragile and conflict affected situations to that in Low & middle income?
Make the answer very short. 0.92. What is the ratio of the Aid flow (current US$) in 1960 in Fragile and conflict affected situations to that in Low income?
Offer a terse response. 0.91. What is the ratio of the Aid flow (current US$) of 1961 in Fragile and conflict affected situations to that in Low income?
Provide a short and direct response. 0.91. What is the ratio of the Aid flow (current US$) in 1962 in Fragile and conflict affected situations to that in Low income?
Ensure brevity in your answer.  0.87. What is the ratio of the Aid flow (current US$) of 1963 in Fragile and conflict affected situations to that in Low income?
Ensure brevity in your answer.  0.92. What is the ratio of the Aid flow (current US$) in 1960 in Fragile and conflict affected situations to that in Sub-Saharan Africa (all income levels)?
Offer a very short reply. 0.91. What is the ratio of the Aid flow (current US$) in 1961 in Fragile and conflict affected situations to that in Sub-Saharan Africa (all income levels)?
Provide a succinct answer. 0.91. What is the ratio of the Aid flow (current US$) of 1962 in Fragile and conflict affected situations to that in Sub-Saharan Africa (all income levels)?
Your answer should be very brief. 0.87. What is the ratio of the Aid flow (current US$) of 1963 in Fragile and conflict affected situations to that in Sub-Saharan Africa (all income levels)?
Provide a succinct answer. 0.92. What is the ratio of the Aid flow (current US$) of 1962 in Heavily indebted poor countries to that in Least developed countries?
Your response must be concise. 1. What is the ratio of the Aid flow (current US$) in 1960 in Heavily indebted poor countries to that in Low & middle income?
Offer a very short reply. 1.05. What is the ratio of the Aid flow (current US$) of 1961 in Heavily indebted poor countries to that in Low & middle income?
Your answer should be compact. 1. What is the ratio of the Aid flow (current US$) in 1962 in Heavily indebted poor countries to that in Low & middle income?
Offer a terse response. 0.98. What is the ratio of the Aid flow (current US$) in 1961 in Heavily indebted poor countries to that in Sub-Saharan Africa (all income levels)?
Your answer should be very brief. 1. What is the ratio of the Aid flow (current US$) in 1962 in Heavily indebted poor countries to that in Sub-Saharan Africa (all income levels)?
Your response must be concise. 1. What is the ratio of the Aid flow (current US$) in 1963 in Heavily indebted poor countries to that in Sub-Saharan Africa (all income levels)?
Give a very brief answer. 1. What is the ratio of the Aid flow (current US$) in 1960 in Least developed countries to that in Low & middle income?
Give a very brief answer. 1.05. What is the ratio of the Aid flow (current US$) in 1962 in Least developed countries to that in Low & middle income?
Your answer should be compact. 0.98. What is the ratio of the Aid flow (current US$) of 1963 in Least developed countries to that in Low & middle income?
Your answer should be compact. 1.01. What is the ratio of the Aid flow (current US$) in 1962 in Least developed countries to that in Low income?
Make the answer very short. 1. What is the ratio of the Aid flow (current US$) of 1963 in Least developed countries to that in Low income?
Make the answer very short. 1. What is the ratio of the Aid flow (current US$) of 1960 in Least developed countries to that in Sub-Saharan Africa (all income levels)?
Offer a very short reply. 1. What is the ratio of the Aid flow (current US$) in 1963 in Least developed countries to that in Sub-Saharan Africa (all income levels)?
Keep it short and to the point. 1. What is the ratio of the Aid flow (current US$) of 1960 in Low & middle income to that in Low income?
Make the answer very short. 0.95. What is the ratio of the Aid flow (current US$) in 1962 in Low & middle income to that in Low income?
Provide a succinct answer. 1.02. What is the ratio of the Aid flow (current US$) of 1963 in Low & middle income to that in Low income?
Offer a terse response. 0.99. What is the ratio of the Aid flow (current US$) of 1960 in Low & middle income to that in Sub-Saharan Africa (all income levels)?
Provide a short and direct response. 0.95. What is the ratio of the Aid flow (current US$) in 1961 in Low & middle income to that in Sub-Saharan Africa (all income levels)?
Your answer should be very brief. 1. What is the ratio of the Aid flow (current US$) of 1962 in Low & middle income to that in Sub-Saharan Africa (all income levels)?
Ensure brevity in your answer.  1.02. What is the ratio of the Aid flow (current US$) in 1963 in Low & middle income to that in Sub-Saharan Africa (all income levels)?
Provide a succinct answer. 0.99. What is the ratio of the Aid flow (current US$) in 1960 in Low income to that in Sub-Saharan Africa (all income levels)?
Provide a succinct answer. 1. What is the ratio of the Aid flow (current US$) in 1962 in Low income to that in Sub-Saharan Africa (all income levels)?
Your answer should be compact. 1. What is the difference between the highest and the second highest Aid flow (current US$) of 1960?
Your answer should be compact. 0. What is the difference between the highest and the second highest Aid flow (current US$) of 1962?
Provide a short and direct response. 1.21e+06. What is the difference between the highest and the lowest Aid flow (current US$) in 1960?
Your response must be concise. 7.50e+06. What is the difference between the highest and the lowest Aid flow (current US$) in 1961?
Your response must be concise. 6.70e+06. What is the difference between the highest and the lowest Aid flow (current US$) in 1962?
Offer a terse response. 9.76e+06. What is the difference between the highest and the lowest Aid flow (current US$) of 1963?
Your answer should be very brief. 6.29e+06. 